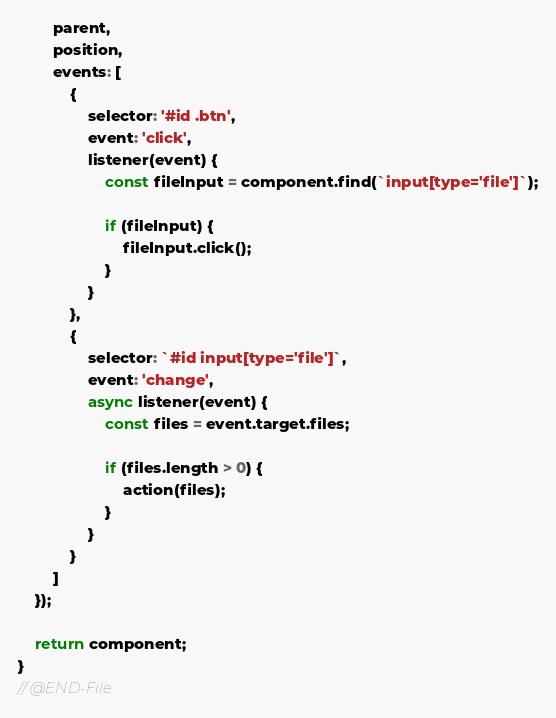Convert code to text. <code><loc_0><loc_0><loc_500><loc_500><_JavaScript_>        parent,
        position,
        events: [
            {
                selector: '#id .btn',
                event: 'click',
                listener(event) {
                    const fileInput = component.find(`input[type='file']`);

                    if (fileInput) {
                        fileInput.click();
                    }
                }
            },
            {
                selector: `#id input[type='file']`,
                event: 'change',
                async listener(event) {
                    const files = event.target.files;

                    if (files.length > 0) {
                        action(files);
                    }
                }
            }
        ]
    });

    return component;
}
// @END-File
</code> 